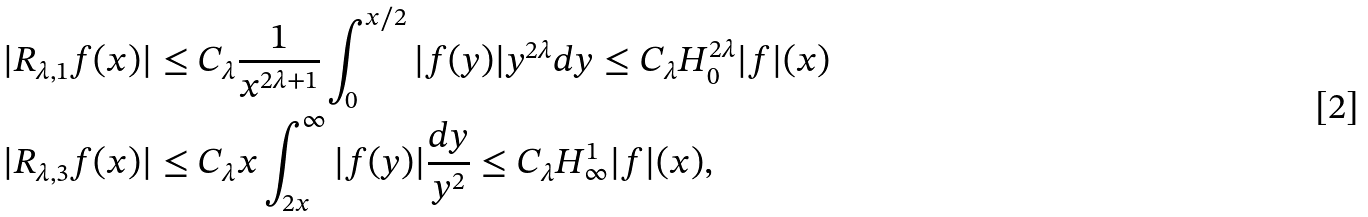<formula> <loc_0><loc_0><loc_500><loc_500>| R _ { \lambda , 1 } f ( x ) | & \leq C _ { \lambda } \frac { 1 } { x ^ { 2 \lambda + 1 } } \int _ { 0 } ^ { x / 2 } | f ( y ) | y ^ { 2 \lambda } d y \leq C _ { \lambda } H _ { 0 } ^ { 2 \lambda } | f | ( x ) \\ | R _ { \lambda , 3 } f ( x ) | & \leq C _ { \lambda } x \int _ { 2 x } ^ { \infty } { | f ( y ) | } \frac { d y } { y ^ { 2 } } \leq C _ { \lambda } H _ { \infty } ^ { 1 } | f | ( x ) ,</formula> 